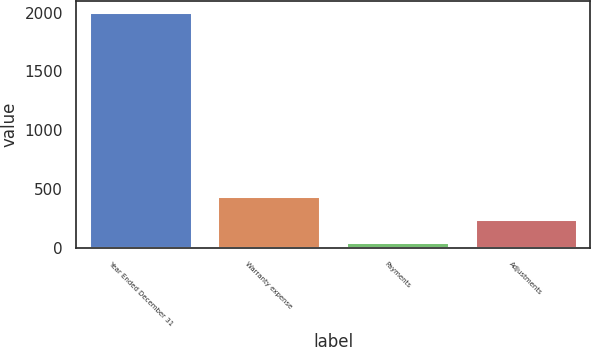<chart> <loc_0><loc_0><loc_500><loc_500><bar_chart><fcel>Year Ended December 31<fcel>Warranty expense<fcel>Payments<fcel>Adjustments<nl><fcel>2003<fcel>441.4<fcel>51<fcel>246.2<nl></chart> 